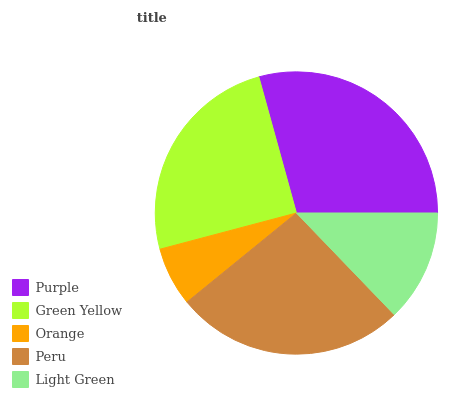Is Orange the minimum?
Answer yes or no. Yes. Is Purple the maximum?
Answer yes or no. Yes. Is Green Yellow the minimum?
Answer yes or no. No. Is Green Yellow the maximum?
Answer yes or no. No. Is Purple greater than Green Yellow?
Answer yes or no. Yes. Is Green Yellow less than Purple?
Answer yes or no. Yes. Is Green Yellow greater than Purple?
Answer yes or no. No. Is Purple less than Green Yellow?
Answer yes or no. No. Is Green Yellow the high median?
Answer yes or no. Yes. Is Green Yellow the low median?
Answer yes or no. Yes. Is Light Green the high median?
Answer yes or no. No. Is Purple the low median?
Answer yes or no. No. 